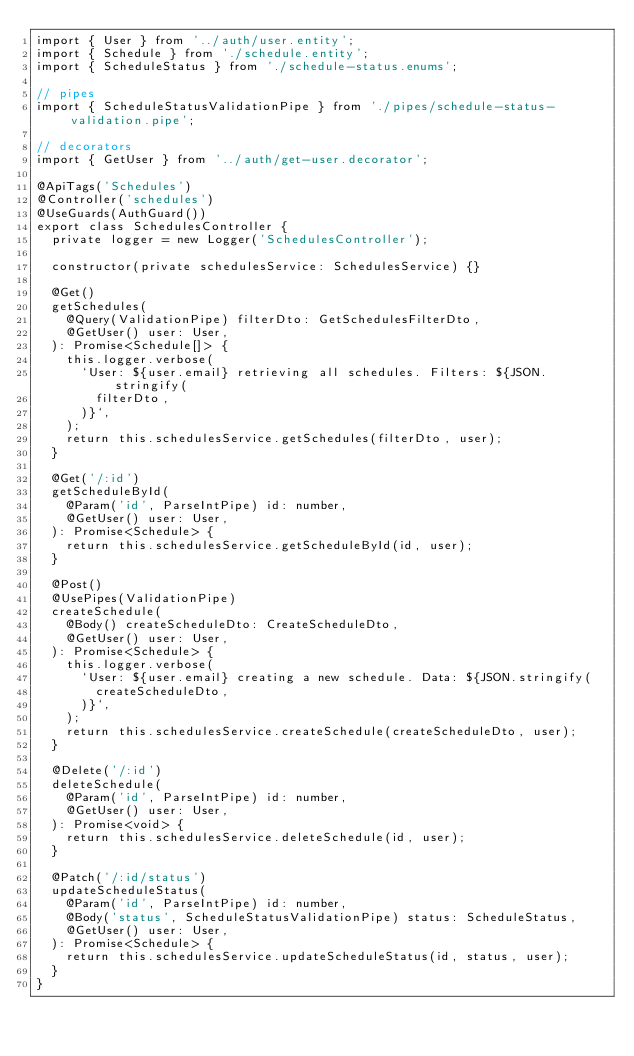<code> <loc_0><loc_0><loc_500><loc_500><_TypeScript_>import { User } from '../auth/user.entity';
import { Schedule } from './schedule.entity';
import { ScheduleStatus } from './schedule-status.enums';

// pipes
import { ScheduleStatusValidationPipe } from './pipes/schedule-status-validation.pipe';

// decorators
import { GetUser } from '../auth/get-user.decorator';

@ApiTags('Schedules')
@Controller('schedules')
@UseGuards(AuthGuard())
export class SchedulesController {
  private logger = new Logger('SchedulesController');

  constructor(private schedulesService: SchedulesService) {}

  @Get()
  getSchedules(
    @Query(ValidationPipe) filterDto: GetSchedulesFilterDto,
    @GetUser() user: User,
  ): Promise<Schedule[]> {
    this.logger.verbose(
      `User: ${user.email} retrieving all schedules. Filters: ${JSON.stringify(
        filterDto,
      )}`,
    );
    return this.schedulesService.getSchedules(filterDto, user);
  }

  @Get('/:id')
  getScheduleById(
    @Param('id', ParseIntPipe) id: number,
    @GetUser() user: User,
  ): Promise<Schedule> {
    return this.schedulesService.getScheduleById(id, user);
  }

  @Post()
  @UsePipes(ValidationPipe)
  createSchedule(
    @Body() createScheduleDto: CreateScheduleDto,
    @GetUser() user: User,
  ): Promise<Schedule> {
    this.logger.verbose(
      `User: ${user.email} creating a new schedule. Data: ${JSON.stringify(
        createScheduleDto,
      )}`,
    );
    return this.schedulesService.createSchedule(createScheduleDto, user);
  }

  @Delete('/:id')
  deleteSchedule(
    @Param('id', ParseIntPipe) id: number,
    @GetUser() user: User,
  ): Promise<void> {
    return this.schedulesService.deleteSchedule(id, user);
  }

  @Patch('/:id/status')
  updateScheduleStatus(
    @Param('id', ParseIntPipe) id: number,
    @Body('status', ScheduleStatusValidationPipe) status: ScheduleStatus,
    @GetUser() user: User,
  ): Promise<Schedule> {
    return this.schedulesService.updateScheduleStatus(id, status, user);
  }
}
</code> 